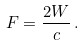Convert formula to latex. <formula><loc_0><loc_0><loc_500><loc_500>F = \frac { 2 W } { c } \, .</formula> 